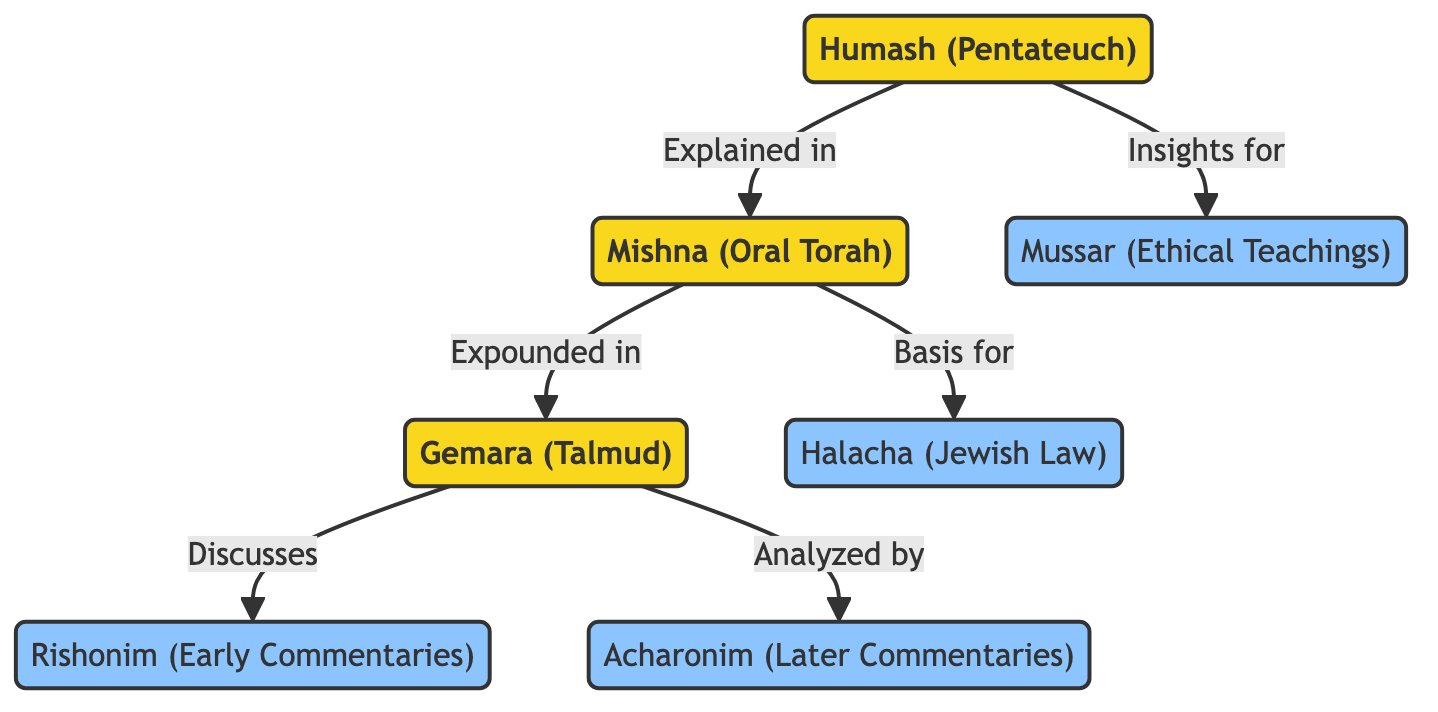What is the primary focus of the Humash? The diagram indicates that the Humash has a primary connection to the Mishna, which means it provides the foundational text for further exploration in Jewish learning.
Answer: Mishna Which text is primarily expounded in the Gemara? The diagram shows an arrow from the Mishna leading to the Gemara, indicating that the Mishna serves as the main source that is further elaborated upon in the Gemara.
Answer: Mishna How many secondary sources are listed in the diagram? There are four sources categorized as secondary in the diagram: Halacha, Rishonim, Acharonim, and Mussar. Counting these gives a total of four secondary nodes.
Answer: 4 What type of teaching does Mussar represent? Mussar is categorized in the diagram under ethical teachings, which represents a distinct aspect of Jewish learning focused on morality and ethics.
Answer: Ethical Teachings What does the Gemara discuss? The diagram indicates that the Gemara discusses the Rishonim, which are early commentaries on Jewish texts, thus showing its role in the broader study of Jewish legal and textual traditions.
Answer: Rishonim Which node directly connects to Halacha? The diagram shows a direct connection from the Mishna to Halacha, indicating that Halacha is derived from the teachings found in the Mishna.
Answer: Mishna In the context of Jewish studies, how are Acharonim related to the Gemara? The diagram depicts an arrow from the Gemara to Acharonim, indicating that the later commentaries (Acharonim) analyze and build upon the discussions found in the Gemara.
Answer: Analyze What is Humash's relationship to Mussar? The diagram shows a direct connection from Humash to Mussar, which indicates that Humash provides insights that inform the ethical teachings within Mussar.
Answer: Insights for 